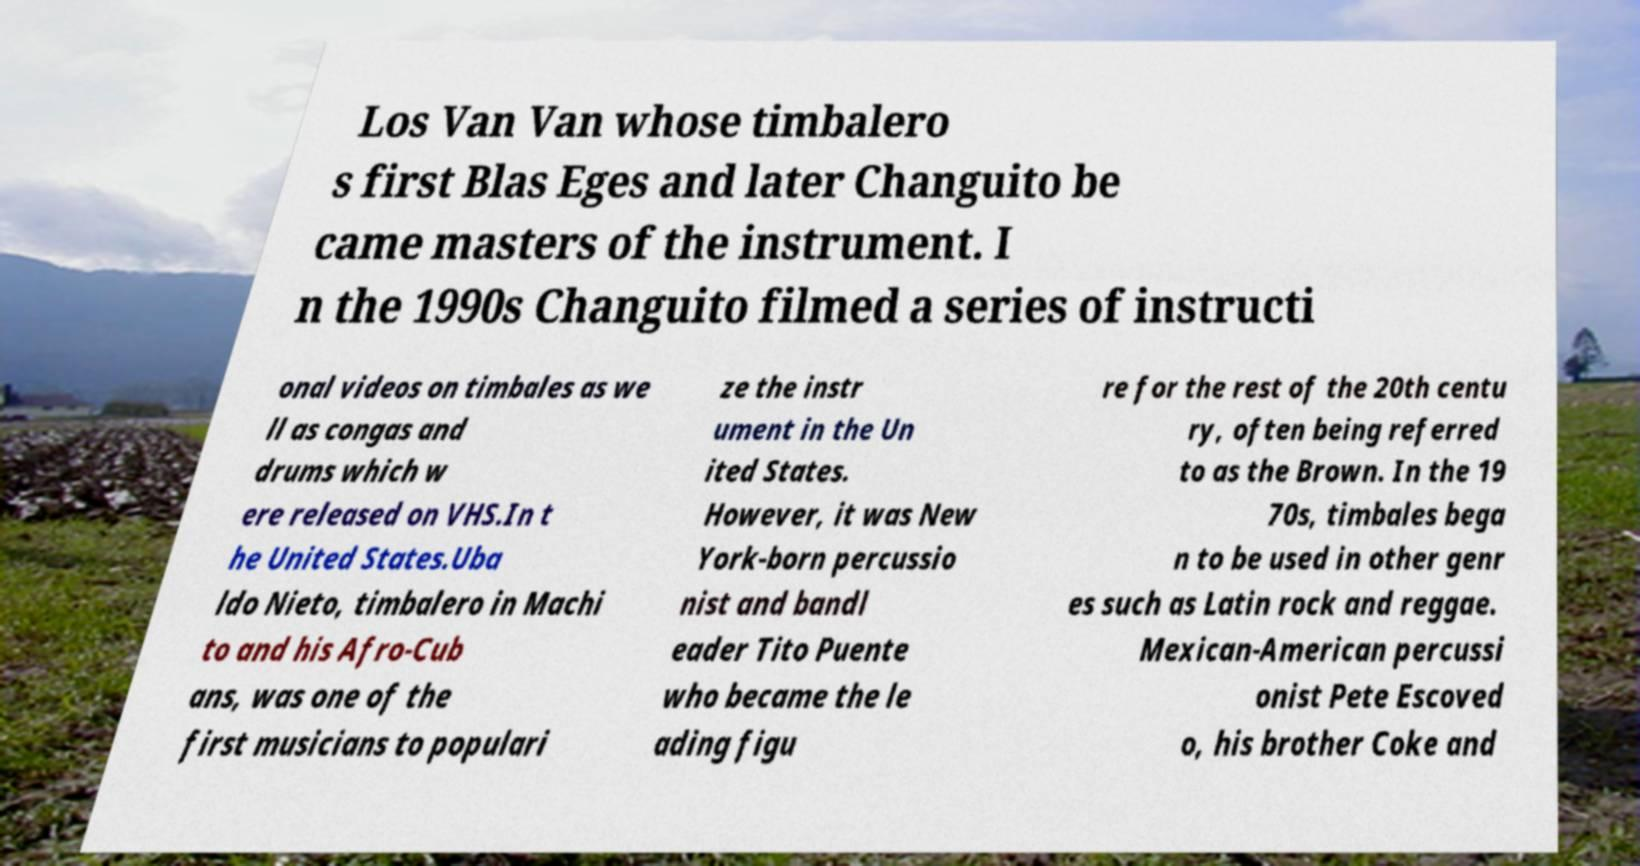What messages or text are displayed in this image? I need them in a readable, typed format. Los Van Van whose timbalero s first Blas Eges and later Changuito be came masters of the instrument. I n the 1990s Changuito filmed a series of instructi onal videos on timbales as we ll as congas and drums which w ere released on VHS.In t he United States.Uba ldo Nieto, timbalero in Machi to and his Afro-Cub ans, was one of the first musicians to populari ze the instr ument in the Un ited States. However, it was New York-born percussio nist and bandl eader Tito Puente who became the le ading figu re for the rest of the 20th centu ry, often being referred to as the Brown. In the 19 70s, timbales bega n to be used in other genr es such as Latin rock and reggae. Mexican-American percussi onist Pete Escoved o, his brother Coke and 